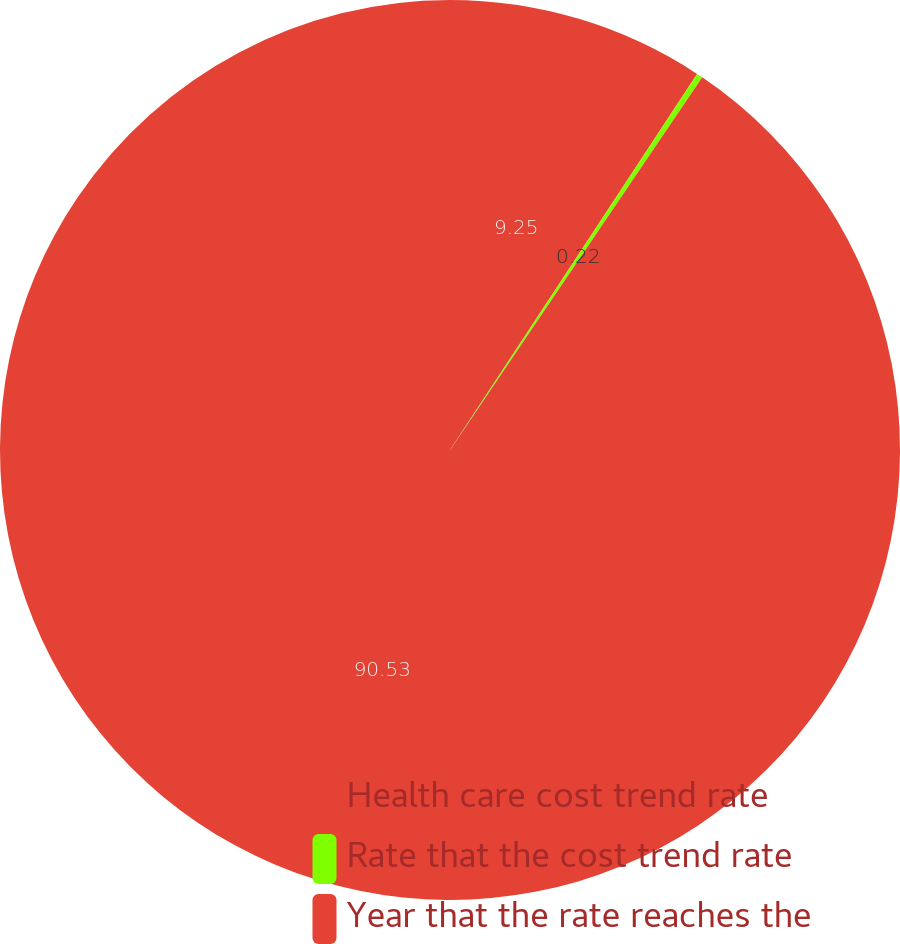Convert chart to OTSL. <chart><loc_0><loc_0><loc_500><loc_500><pie_chart><fcel>Health care cost trend rate<fcel>Rate that the cost trend rate<fcel>Year that the rate reaches the<nl><fcel>9.25%<fcel>0.22%<fcel>90.52%<nl></chart> 